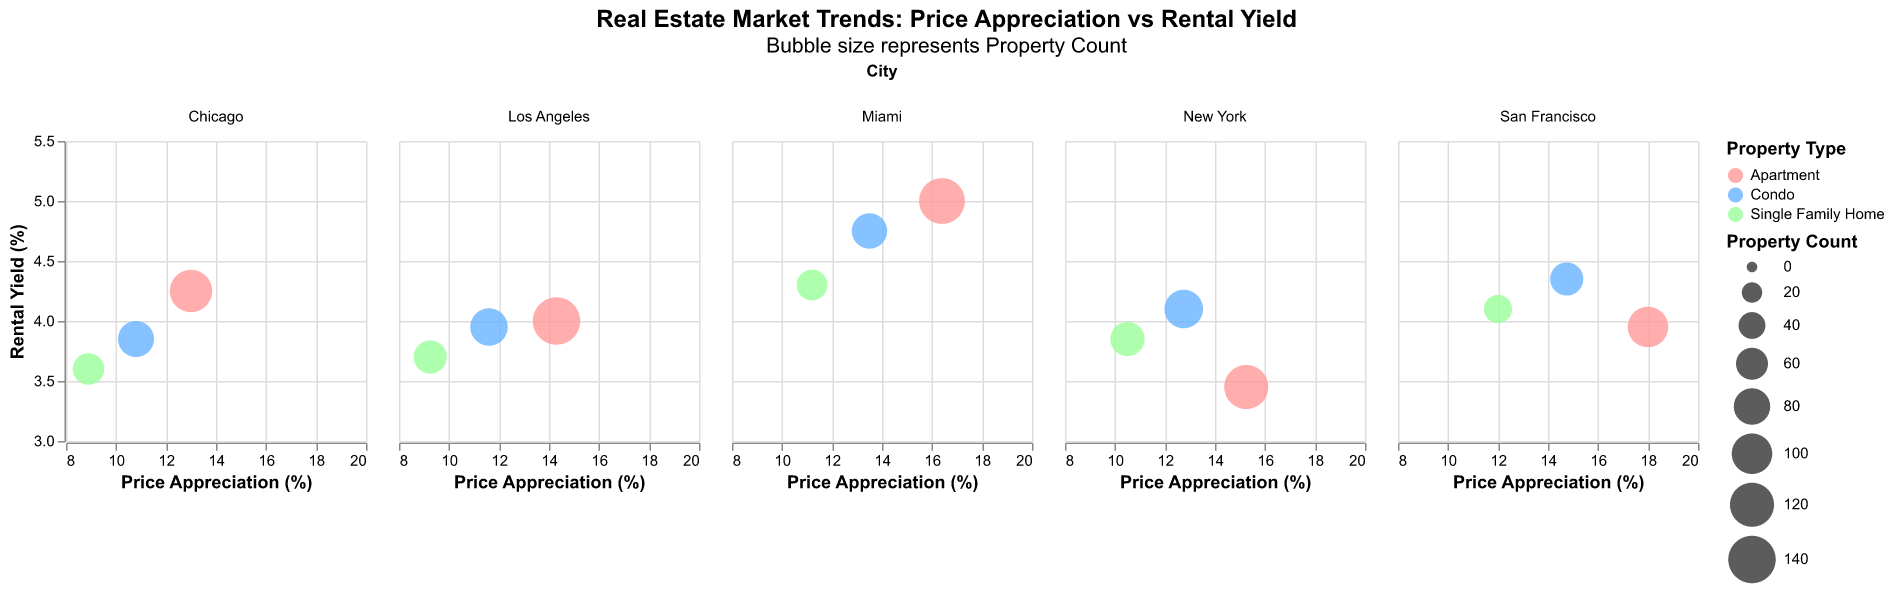What's the title of the figure? The title of the figure is usually displayed at the top. It provides an immediate understanding of what the figure represents.
Answer: Real Estate Market Trends: Price Appreciation vs Rental Yield Which city has the highest price appreciation overall? By examining the x-axis (Price Appreciation) for each subplot (representing different cities), San Francisco shows the highest price appreciation among all property types.
Answer: San Francisco Which property type in Miami has the highest rental yield? In the Miami subplot, look for the highest point on the y-axis (Rental Yield). The point associated with 'Apartment' has the highest value.
Answer: Apartment How many different property types are color-coded in the entire figure? By observing the color legend, you can see there are three distinct property types: Apartment, Condo, and Single Family Home.
Answer: Three What is the average rental yield for Single Family Homes in Chicago and Miami? Identify the Rental Yield values for Single Family Homes in both cities: Chicago (3.60) and Miami (4.30). The average is calculated as (3.60 + 4.30) / 2.
Answer: 3.95 Which city has the highest property count for Apartments? Check the sizes of the circles representing Apartments in each city. Los Angeles has the largest circle for Apartments.
Answer: Los Angeles What's the difference in price appreciation between Condos in New York and San Francisco? Find the Price Appreciation values for Condos: New York (12.75) and San Francisco (14.75). The difference is calculated as 14.75 - 12.75.
Answer: 2.0 Which city has the lowest price appreciation for Single Family Homes? Compare the x-axis values of Single Family Homes across all subplots. Chicago has the lowest value (8.90).
Answer: Chicago Does any property type in New York have a higher rental yield than those in Los Angeles? Compare the y-axis values (Rental Yield) of property types in New York to those in Los Angeles. New York's Condo (4.10) has a higher rental yield than all property types in Los Angeles.
Answer: Yes Between Condos and Apartments in Miami, which has a higher price appreciation and by how much? In the Miami subplot, compare the x-axis values for Condos (13.50) and Apartments (16.40). The difference is 16.40 - 13.50.
Answer: Apartments, by 2.90 